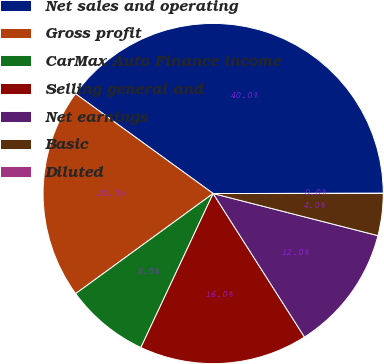Convert chart to OTSL. <chart><loc_0><loc_0><loc_500><loc_500><pie_chart><fcel>Net sales and operating<fcel>Gross profit<fcel>CarMax Auto Finance income<fcel>Selling general and<fcel>Net earnings<fcel>Basic<fcel>Diluted<nl><fcel>40.0%<fcel>20.0%<fcel>8.0%<fcel>16.0%<fcel>12.0%<fcel>4.0%<fcel>0.0%<nl></chart> 